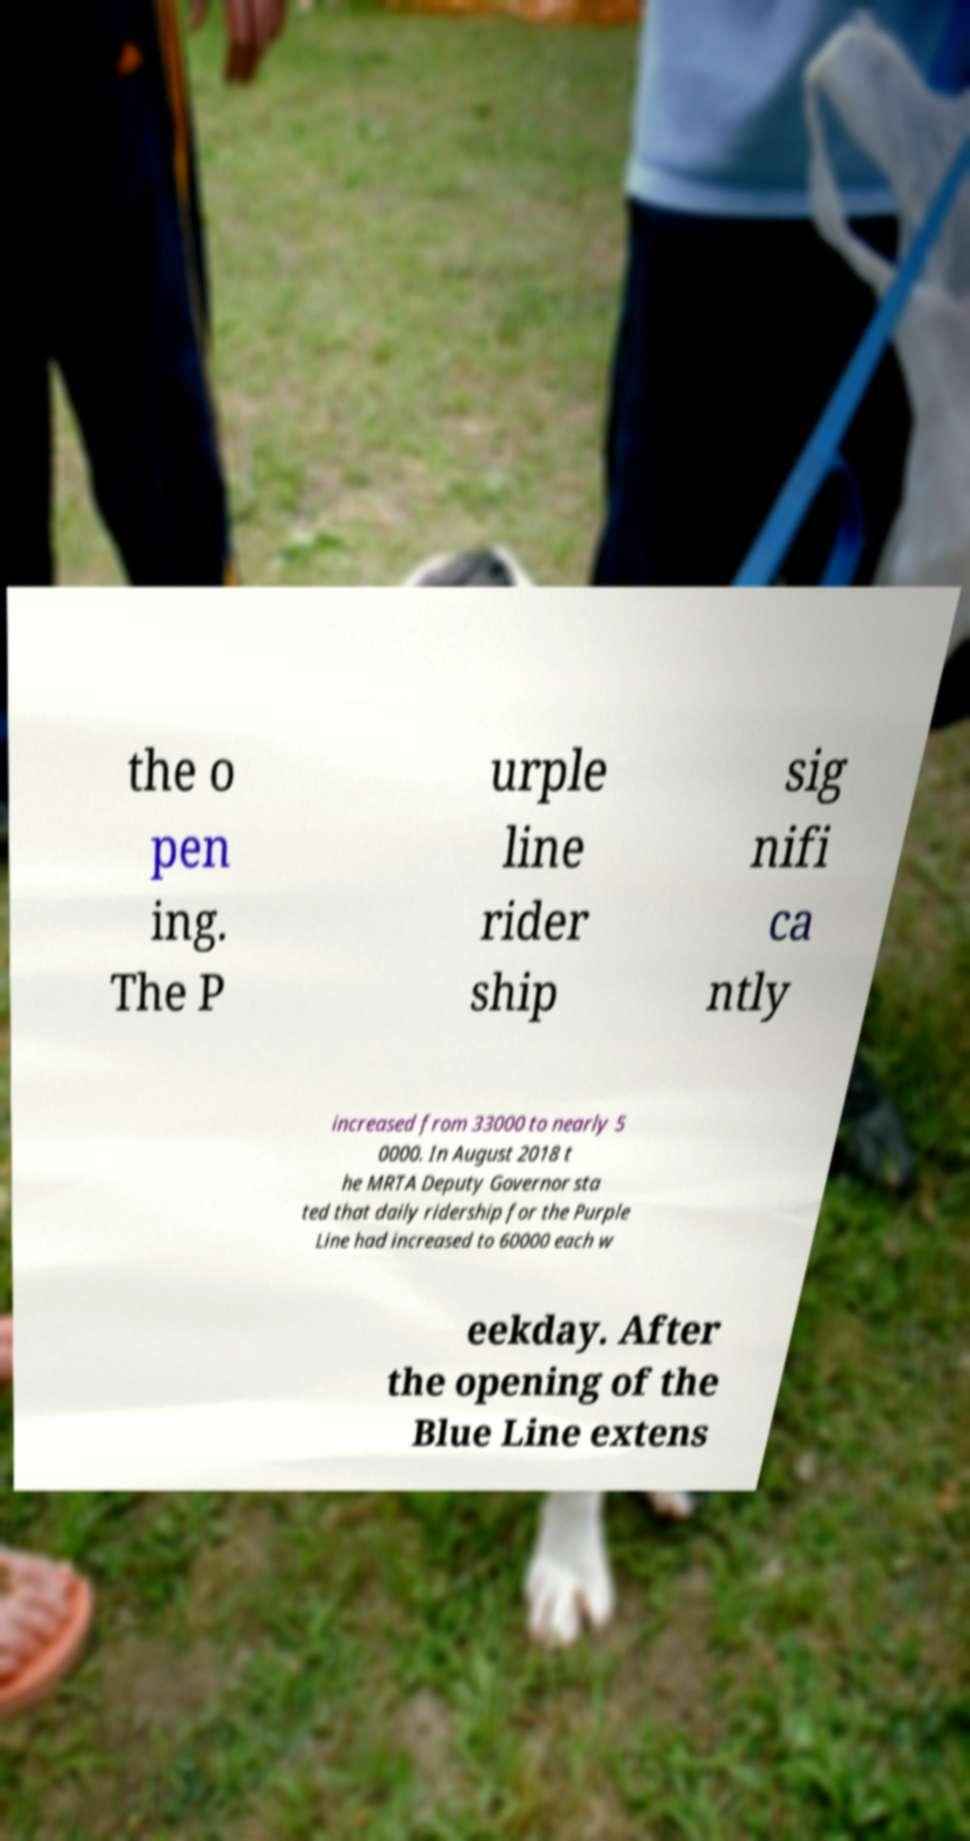Could you assist in decoding the text presented in this image and type it out clearly? the o pen ing. The P urple line rider ship sig nifi ca ntly increased from 33000 to nearly 5 0000. In August 2018 t he MRTA Deputy Governor sta ted that daily ridership for the Purple Line had increased to 60000 each w eekday. After the opening of the Blue Line extens 